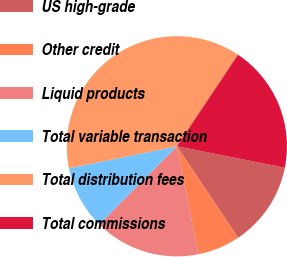Convert chart to OTSL. <chart><loc_0><loc_0><loc_500><loc_500><pie_chart><fcel>US high-grade<fcel>Other credit<fcel>Liquid products<fcel>Total variable transaction<fcel>Total distribution fees<fcel>Total commissions<nl><fcel>12.49%<fcel>6.22%<fcel>15.62%<fcel>9.35%<fcel>37.57%<fcel>18.76%<nl></chart> 